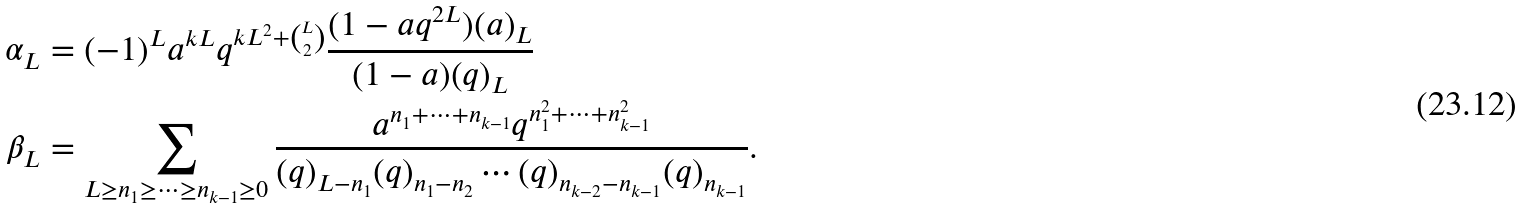<formula> <loc_0><loc_0><loc_500><loc_500>\alpha _ { L } & = ( - 1 ) ^ { L } a ^ { k L } q ^ { k L ^ { 2 } + \binom { L } { 2 } } \frac { ( 1 - a q ^ { 2 L } ) ( a ) _ { L } } { ( 1 - a ) ( q ) _ { L } } \\ \beta _ { L } & = \sum _ { L \geq n _ { 1 } \geq \dots \geq n _ { k - 1 } \geq 0 } \frac { a ^ { n _ { 1 } + \cdots + n _ { k - 1 } } q ^ { n _ { 1 } ^ { 2 } + \cdots + n _ { k - 1 } ^ { 2 } } } { ( q ) _ { L - n _ { 1 } } ( q ) _ { n _ { 1 } - n _ { 2 } } \cdots ( q ) _ { n _ { k - 2 } - n _ { k - 1 } } ( q ) _ { n _ { k - 1 } } } .</formula> 